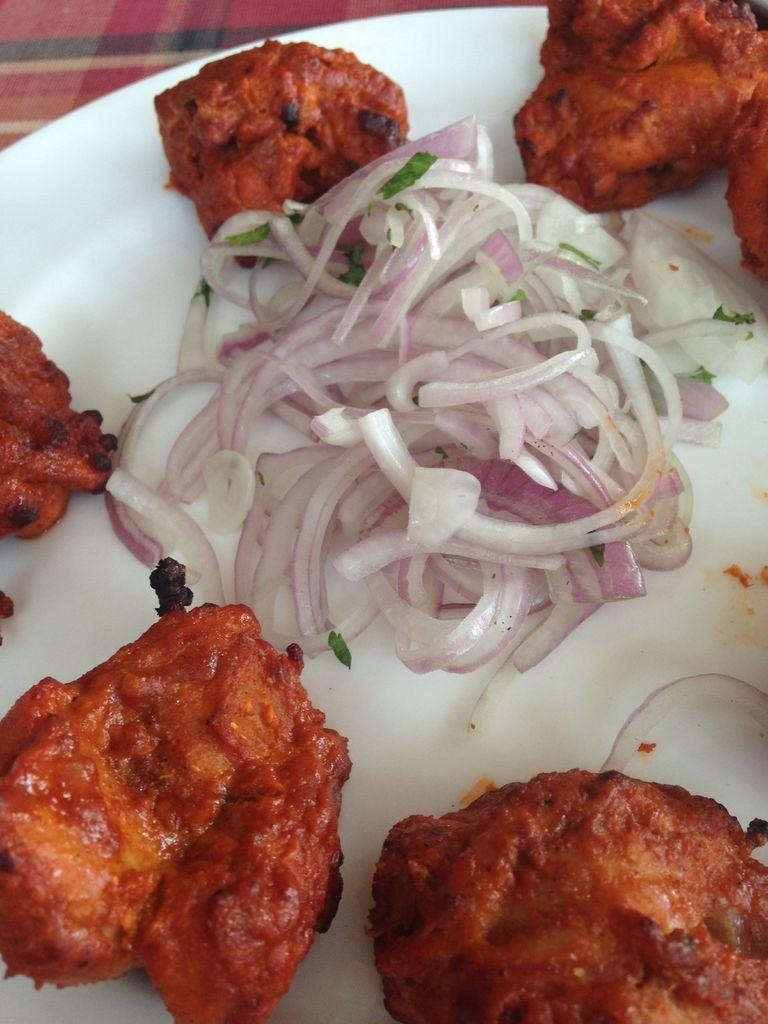What is present on the plate in the image? There is a food item on the plate in the image. What type of bone can be seen in the image? There is no bone present in the image; it only features a plate with a food item on it. 